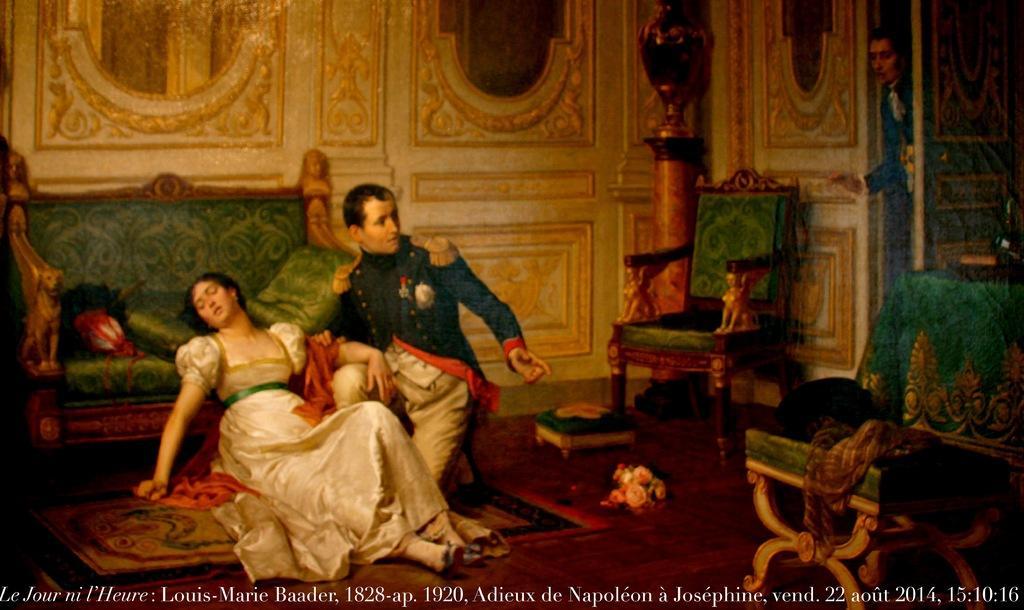How would you summarize this image in a sentence or two? In this picture we can see man and woman where man is sitting on knees and woman is sitting on floor and at back of them we can see sofa with pillows on it and beside to them we have chairs, stool and in background we can see wall, some person standing at door. 